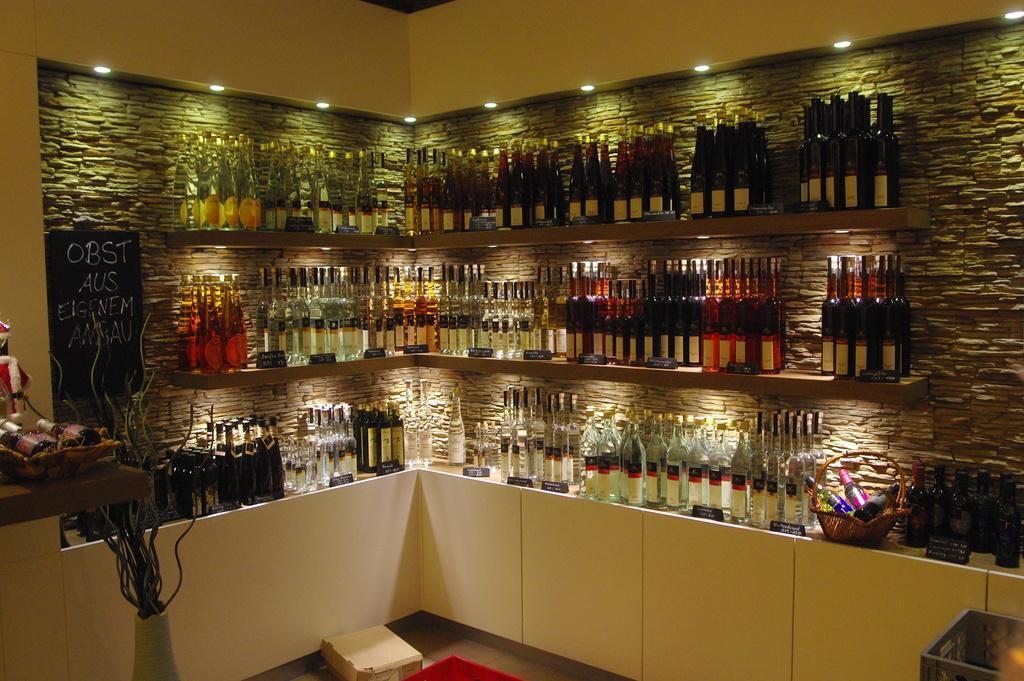How would you summarize this image in a sentence or two? In the picture we can see many bottles are placed on the shelves. Here we can see a basket and few objects a placed on the table and we can see the lights and board here. 